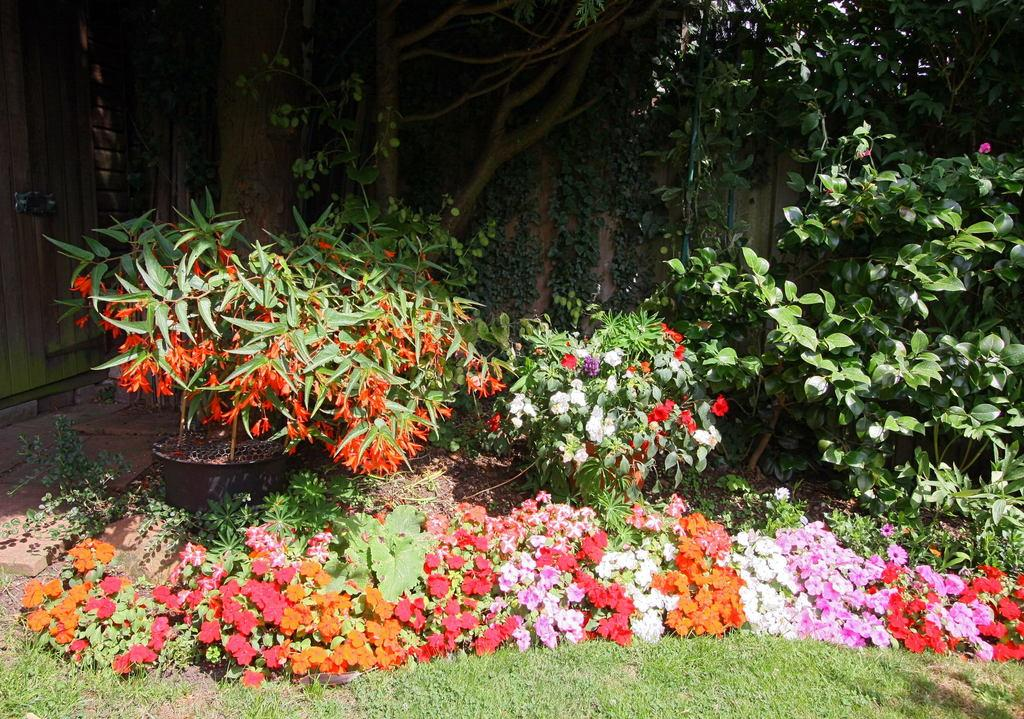What type of vegetation can be seen in the image? There is grass, flowers, and plants visible in the image. What can be seen in the background of the image? There are trees in the background of the image. What type of grain can be seen in the image? There is no grain present in the image; it features grass, flowers, and plants. 